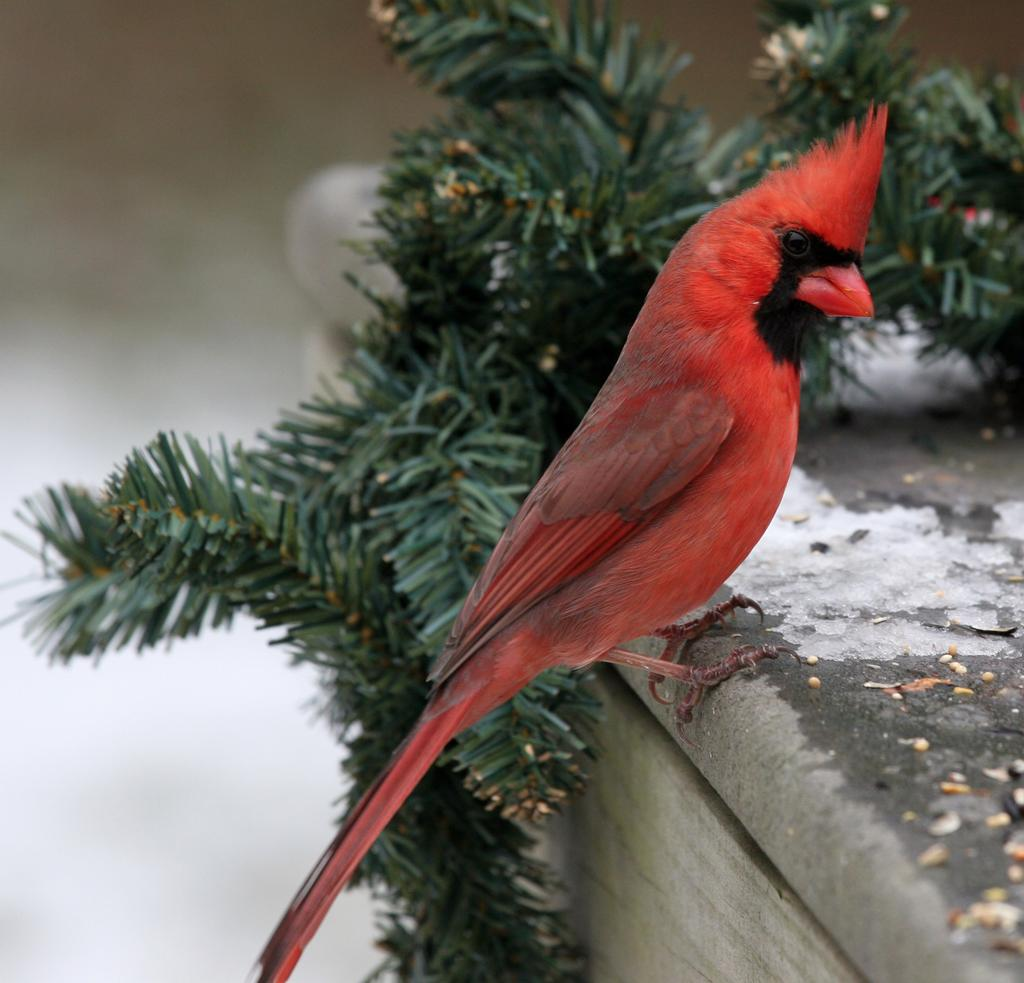What animal can be seen in the image? There is a bird in the image. Where is the bird located? The bird is sitting on a stone. What type of vegetation is present in the image? There are green leaves in the image. How would you describe the background of the image? The background of the image is blurred. What type of flame can be seen near the bird in the image? There is no flame present in the image; it features a bird sitting on a stone with green leaves in the background. 